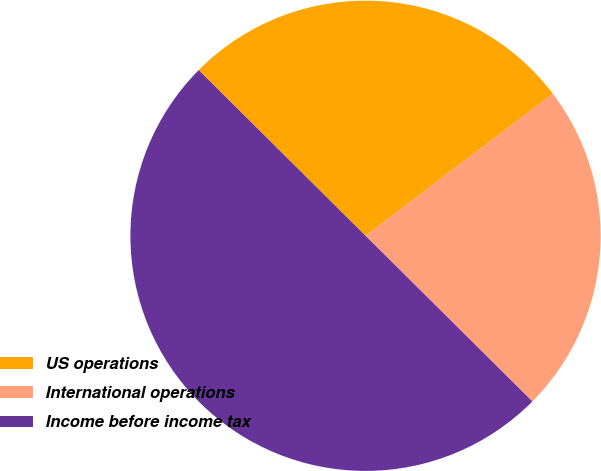Convert chart to OTSL. <chart><loc_0><loc_0><loc_500><loc_500><pie_chart><fcel>US operations<fcel>International operations<fcel>Income before income tax<nl><fcel>27.23%<fcel>22.77%<fcel>50.0%<nl></chart> 